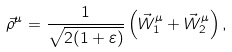Convert formula to latex. <formula><loc_0><loc_0><loc_500><loc_500>\vec { \rho } ^ { \mu } = \frac { 1 } { \sqrt { 2 ( 1 + \varepsilon ) } } \left ( \vec { W } _ { 1 } ^ { \mu } + \vec { W } _ { 2 } ^ { \mu } \right ) ,</formula> 